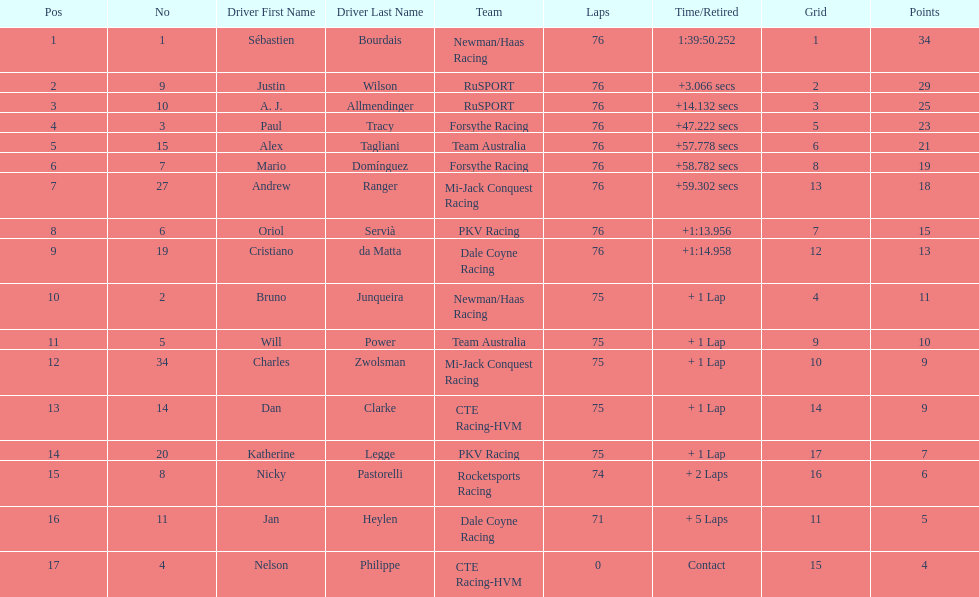Which driver has the least amount of points? Nelson Philippe. 